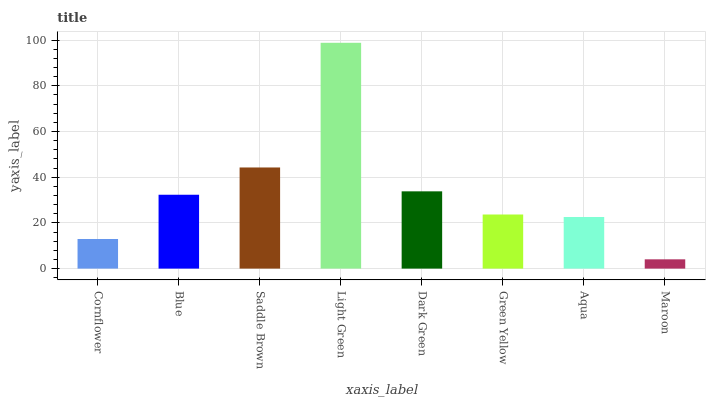Is Maroon the minimum?
Answer yes or no. Yes. Is Light Green the maximum?
Answer yes or no. Yes. Is Blue the minimum?
Answer yes or no. No. Is Blue the maximum?
Answer yes or no. No. Is Blue greater than Cornflower?
Answer yes or no. Yes. Is Cornflower less than Blue?
Answer yes or no. Yes. Is Cornflower greater than Blue?
Answer yes or no. No. Is Blue less than Cornflower?
Answer yes or no. No. Is Blue the high median?
Answer yes or no. Yes. Is Green Yellow the low median?
Answer yes or no. Yes. Is Cornflower the high median?
Answer yes or no. No. Is Light Green the low median?
Answer yes or no. No. 